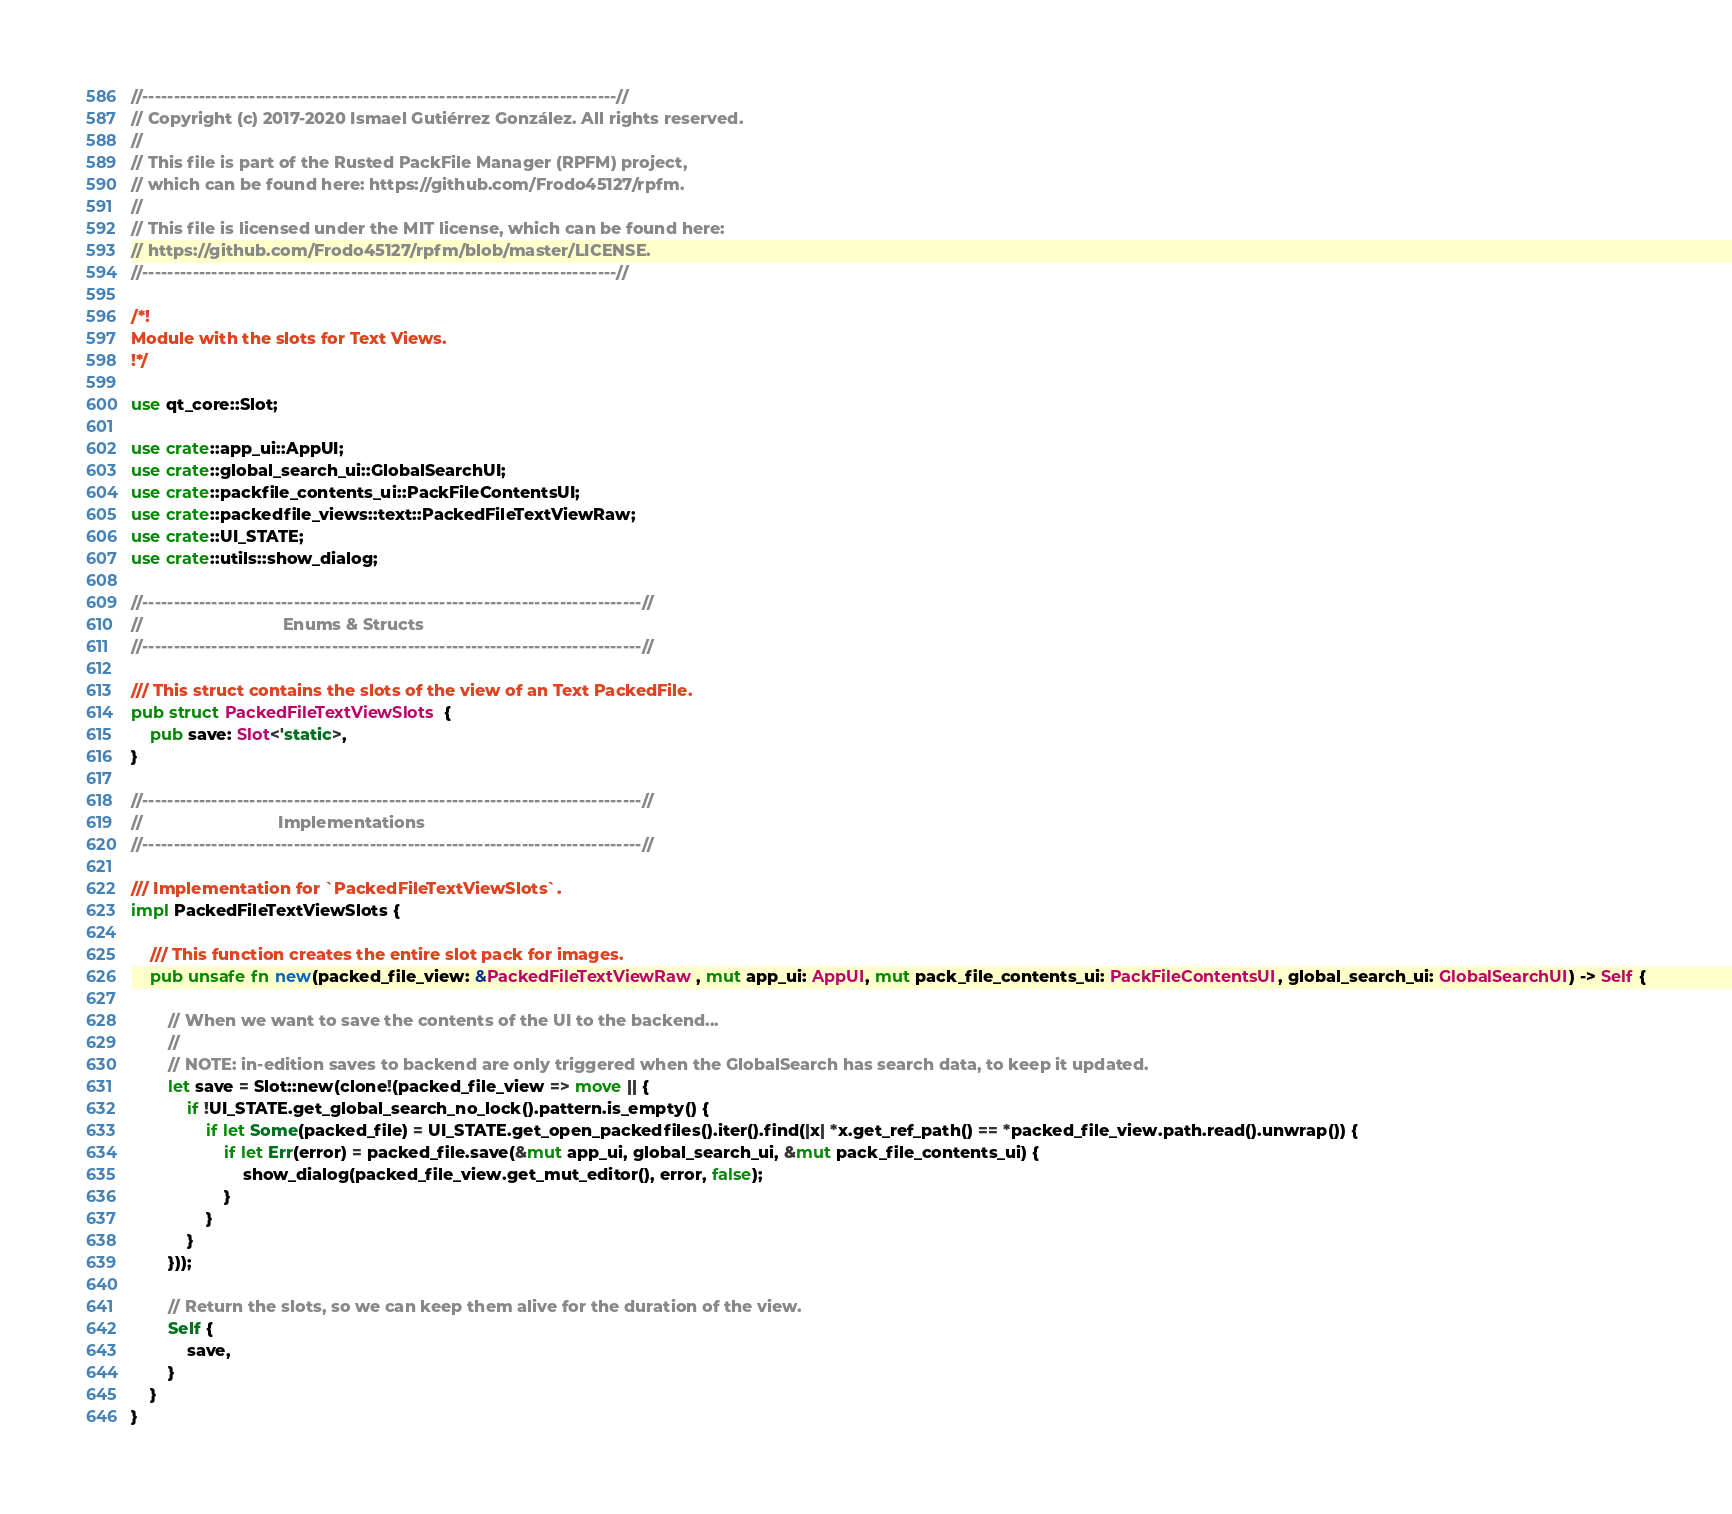<code> <loc_0><loc_0><loc_500><loc_500><_Rust_>//---------------------------------------------------------------------------//
// Copyright (c) 2017-2020 Ismael Gutiérrez González. All rights reserved.
//
// This file is part of the Rusted PackFile Manager (RPFM) project,
// which can be found here: https://github.com/Frodo45127/rpfm.
//
// This file is licensed under the MIT license, which can be found here:
// https://github.com/Frodo45127/rpfm/blob/master/LICENSE.
//---------------------------------------------------------------------------//

/*!
Module with the slots for Text Views.
!*/

use qt_core::Slot;

use crate::app_ui::AppUI;
use crate::global_search_ui::GlobalSearchUI;
use crate::packfile_contents_ui::PackFileContentsUI;
use crate::packedfile_views::text::PackedFileTextViewRaw;
use crate::UI_STATE;
use crate::utils::show_dialog;

//-------------------------------------------------------------------------------//
//                              Enums & Structs
//-------------------------------------------------------------------------------//

/// This struct contains the slots of the view of an Text PackedFile.
pub struct PackedFileTextViewSlots {
    pub save: Slot<'static>,
}

//-------------------------------------------------------------------------------//
//                             Implementations
//-------------------------------------------------------------------------------//

/// Implementation for `PackedFileTextViewSlots`.
impl PackedFileTextViewSlots {

    /// This function creates the entire slot pack for images.
    pub unsafe fn new(packed_file_view: &PackedFileTextViewRaw, mut app_ui: AppUI, mut pack_file_contents_ui: PackFileContentsUI, global_search_ui: GlobalSearchUI) -> Self {

        // When we want to save the contents of the UI to the backend...
        //
        // NOTE: in-edition saves to backend are only triggered when the GlobalSearch has search data, to keep it updated.
        let save = Slot::new(clone!(packed_file_view => move || {
            if !UI_STATE.get_global_search_no_lock().pattern.is_empty() {
                if let Some(packed_file) = UI_STATE.get_open_packedfiles().iter().find(|x| *x.get_ref_path() == *packed_file_view.path.read().unwrap()) {
                    if let Err(error) = packed_file.save(&mut app_ui, global_search_ui, &mut pack_file_contents_ui) {
                        show_dialog(packed_file_view.get_mut_editor(), error, false);
                    }
                }
            }
        }));

        // Return the slots, so we can keep them alive for the duration of the view.
        Self {
            save,
        }
    }
}
</code> 